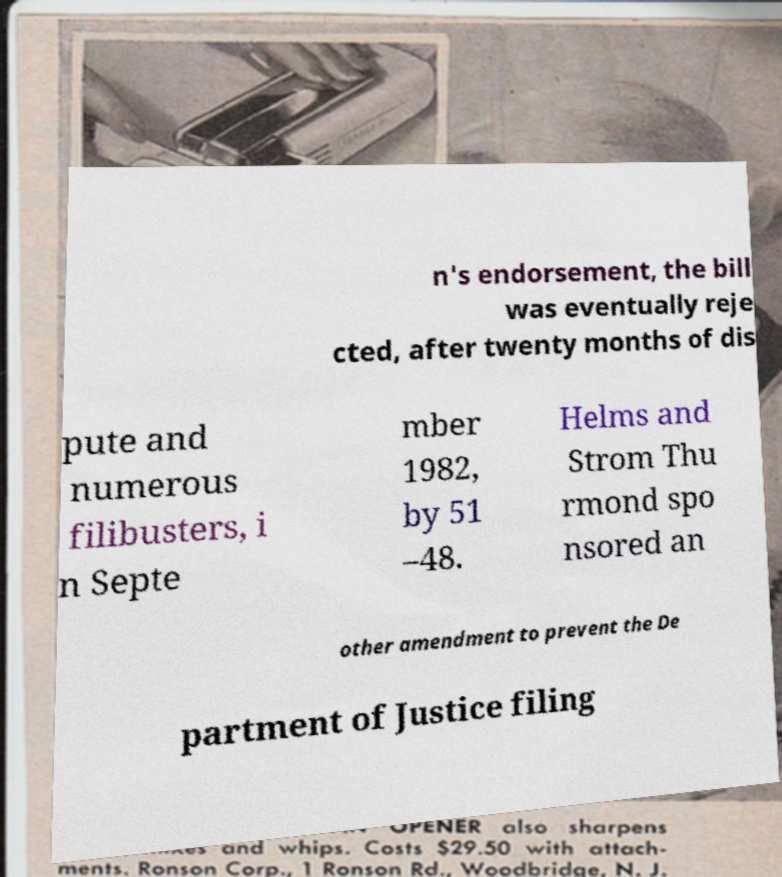I need the written content from this picture converted into text. Can you do that? n's endorsement, the bill was eventually reje cted, after twenty months of dis pute and numerous filibusters, i n Septe mber 1982, by 51 –48. Helms and Strom Thu rmond spo nsored an other amendment to prevent the De partment of Justice filing 